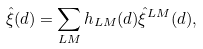<formula> <loc_0><loc_0><loc_500><loc_500>\hat { \xi } ( d ) = \sum _ { L M } h _ { L M } ( d ) \hat { \xi } ^ { L M } ( d ) ,</formula> 